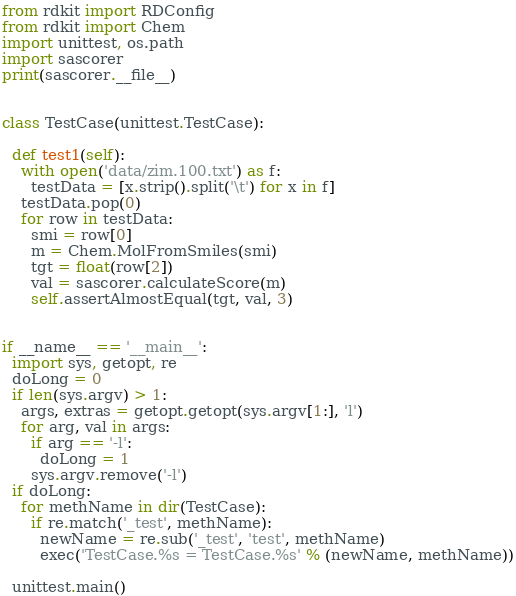<code> <loc_0><loc_0><loc_500><loc_500><_Python_>
from rdkit import RDConfig
from rdkit import Chem
import unittest, os.path
import sascorer
print(sascorer.__file__)


class TestCase(unittest.TestCase):

  def test1(self):
    with open('data/zim.100.txt') as f:
      testData = [x.strip().split('\t') for x in f]
    testData.pop(0)
    for row in testData:
      smi = row[0]
      m = Chem.MolFromSmiles(smi)
      tgt = float(row[2])
      val = sascorer.calculateScore(m)
      self.assertAlmostEqual(tgt, val, 3)


if __name__ == '__main__':
  import sys, getopt, re
  doLong = 0
  if len(sys.argv) > 1:
    args, extras = getopt.getopt(sys.argv[1:], 'l')
    for arg, val in args:
      if arg == '-l':
        doLong = 1
      sys.argv.remove('-l')
  if doLong:
    for methName in dir(TestCase):
      if re.match('_test', methName):
        newName = re.sub('_test', 'test', methName)
        exec('TestCase.%s = TestCase.%s' % (newName, methName))

  unittest.main()
</code> 